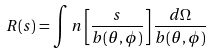<formula> <loc_0><loc_0><loc_500><loc_500>R ( s ) = \int n \left [ \frac { s } { b ( \theta , \phi ) } \right ] \frac { d \Omega } { b ( \theta , \phi ) }</formula> 